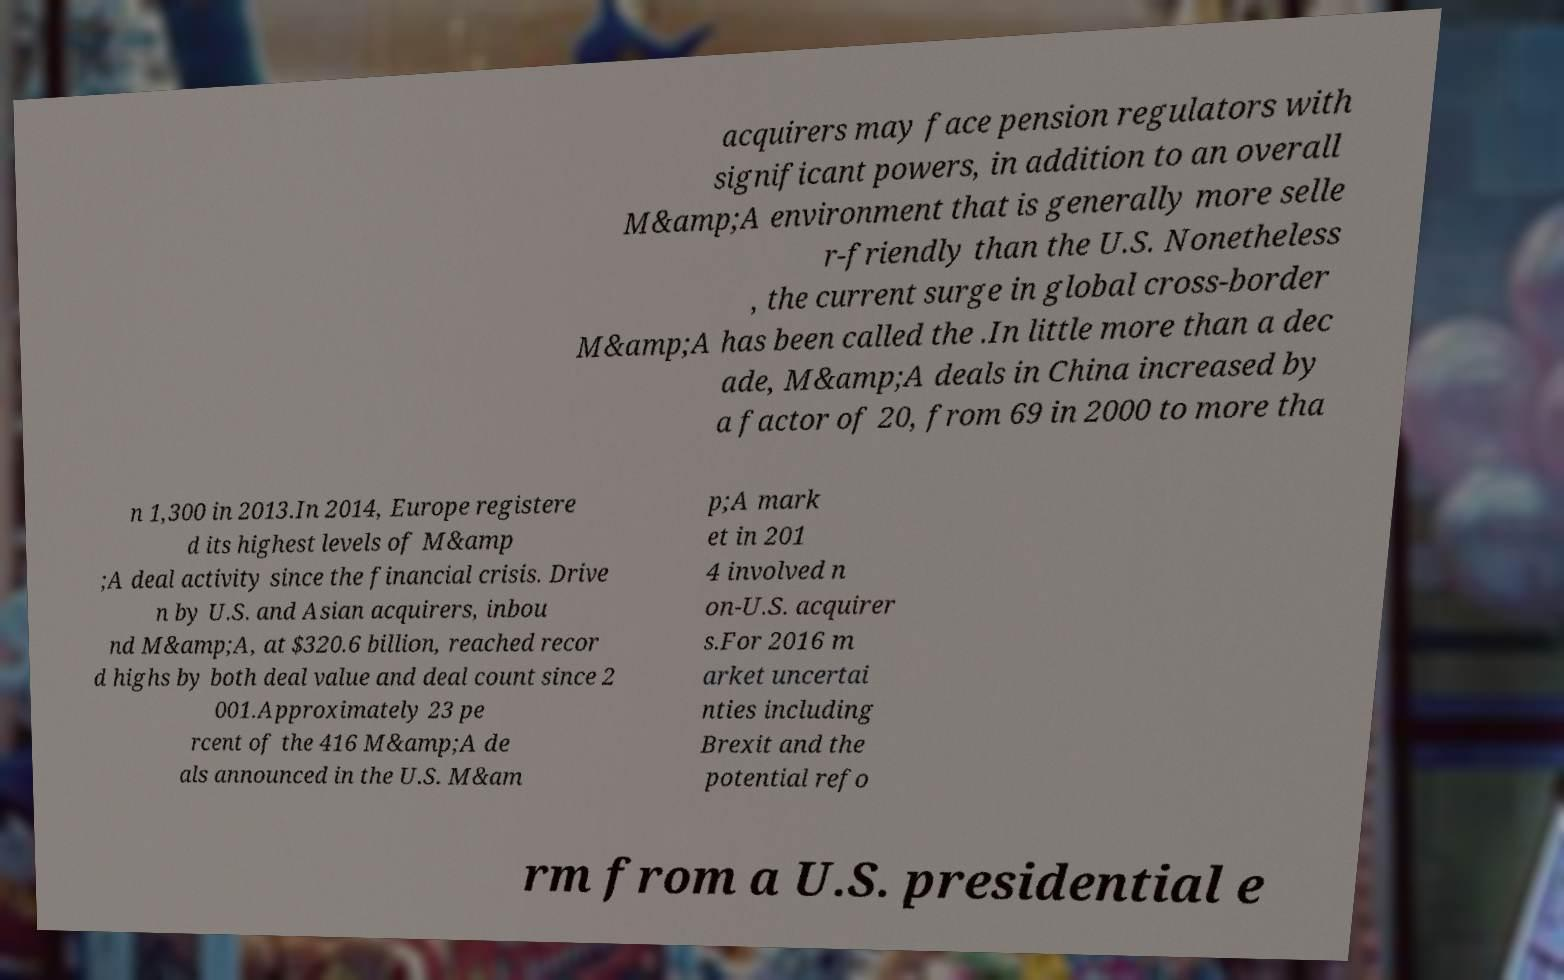Please identify and transcribe the text found in this image. acquirers may face pension regulators with significant powers, in addition to an overall M&amp;A environment that is generally more selle r-friendly than the U.S. Nonetheless , the current surge in global cross-border M&amp;A has been called the .In little more than a dec ade, M&amp;A deals in China increased by a factor of 20, from 69 in 2000 to more tha n 1,300 in 2013.In 2014, Europe registere d its highest levels of M&amp ;A deal activity since the financial crisis. Drive n by U.S. and Asian acquirers, inbou nd M&amp;A, at $320.6 billion, reached recor d highs by both deal value and deal count since 2 001.Approximately 23 pe rcent of the 416 M&amp;A de als announced in the U.S. M&am p;A mark et in 201 4 involved n on-U.S. acquirer s.For 2016 m arket uncertai nties including Brexit and the potential refo rm from a U.S. presidential e 